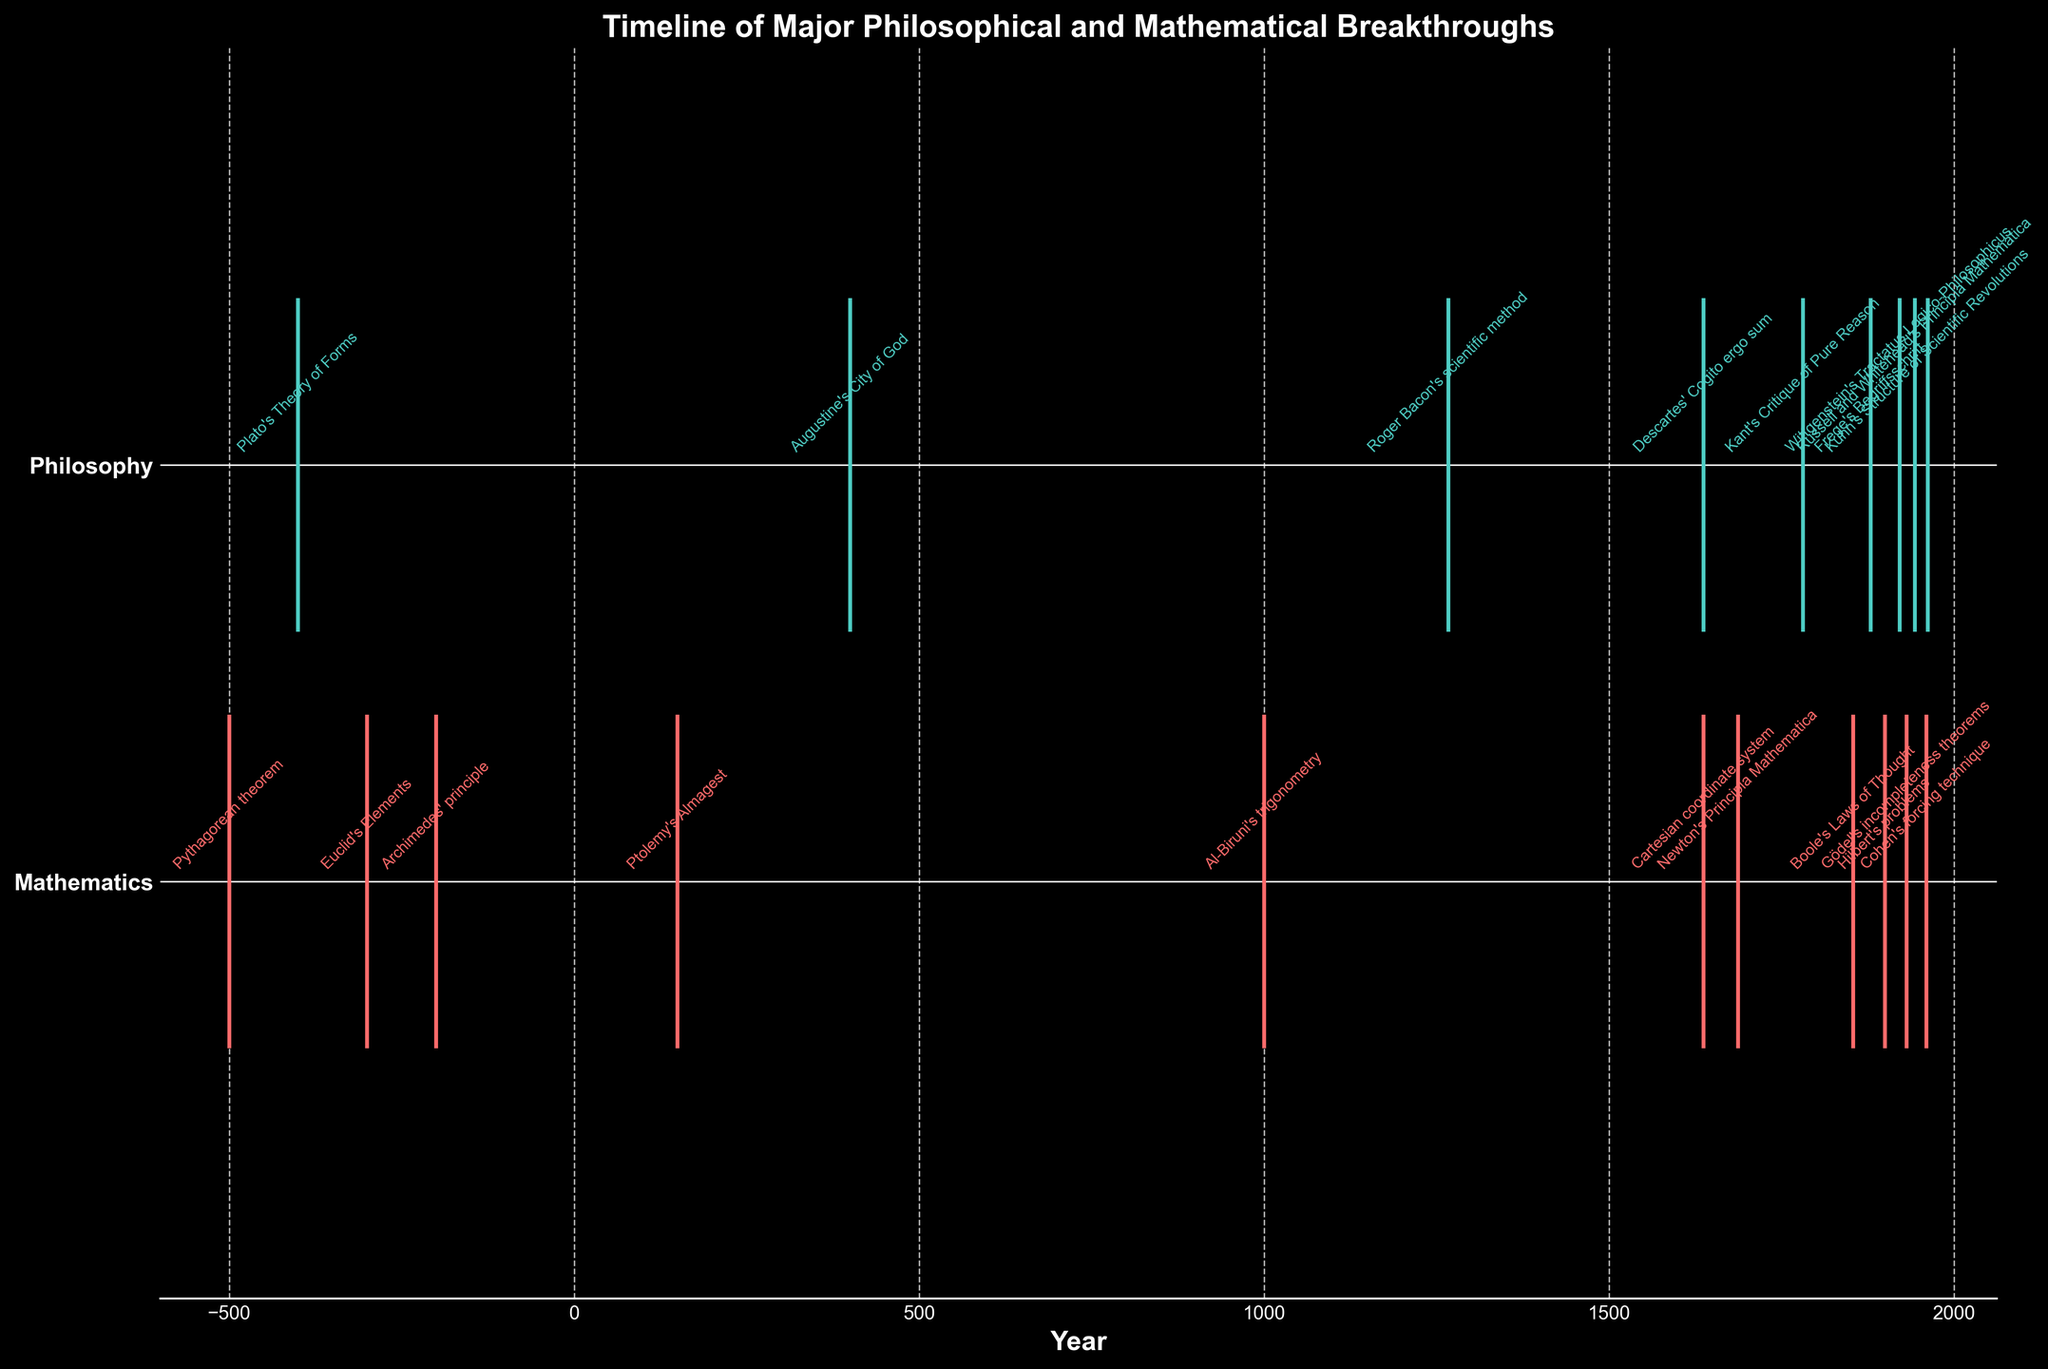What are the two categories represented in the figure? The y-axis labels on the eventplot show two categories: "Mathematics" and "Philosophy".
Answer: Mathematics and Philosophy Which event happened around 1637 that is related to Mathematics? To find the event related to Mathematics in 1637, look for the data point on the timeline for Mathematics around the year 1637. The annotated text there indicates the "Cartesian coordinate system" event.
Answer: Cartesian coordinate system Which category has more events represented, Philosophy or Mathematics? Count the number of events for each category as marked on the figure. Philosophy has fewer events than Mathematics.
Answer: Mathematics What is the earliest event recorded in the Philosophy category? On the timeline, the Philosophy category's earliest event is annotated around -400. This event is "Plato's Theory of Forms".
Answer: Plato's Theory of Forms Are there any years with events listed in both categories? If so, which year? Check the timeline for years that have annotations for both Philosophy and Mathematics categories. The year 1637 shows events in both categories: "Descartes' Cogito ergo sum" in Philosophy and "Cartesian coordinate system" in Mathematics.
Answer: 1637 How far apart in years are the earliest Philosophy and earliest Mathematics events? The earliest Philosophy event is in -400 ("Plato's Theory of Forms"), and the earliest Mathematics event is in -500 ("Pythagorean theorem"). The difference is 100 years.
Answer: 100 years Which event in the Mathematics category happened closest to the year 150? Check the events in Mathematics around the year 150 on the timeline. The closest event is "Ptolemy's Almagest" at precisely 150.
Answer: Ptolemy's Almagest Which event marks the closest gap in years for any category? Find the shortest time interval between events in any category. On checking the dates, the shortest gap is between "Descartes' Cogito ergo sum" and "Cartesian coordinate system", both occurring in 1637.
Answer: Descartes' Cogito ergo sum and Cartesian coordinate system What philosophical work was published furthest from the year 0? Look at the Philosophy timeline to find the work annotated farthest from year 0. The farthest work is "Roger Bacon's scientific method" in the year 1267.
Answer: Roger Bacon's scientific method Which mathematical breakthrough took place after 1800? Look for events in the Mathematics timeline after the year 1800. Events that satisfy this are "Boole's Laws of Thought" (1854), "Frege's Begriffsschrift" (1879), "Hilbert's problems" (1900), "Gödel's incompleteness theorems" (1931), "Russell and Whitehead's Principia Mathematica" (1943), and "Cohen's forcing technique" (1960).
Answer: Boole's Laws of Thought, Frege's Begriffsschrift, Hilbert's problems, Gödel's incompleteness theorems, Russell and Whitehead's Principia Mathematica, Cohen's forcing technique 